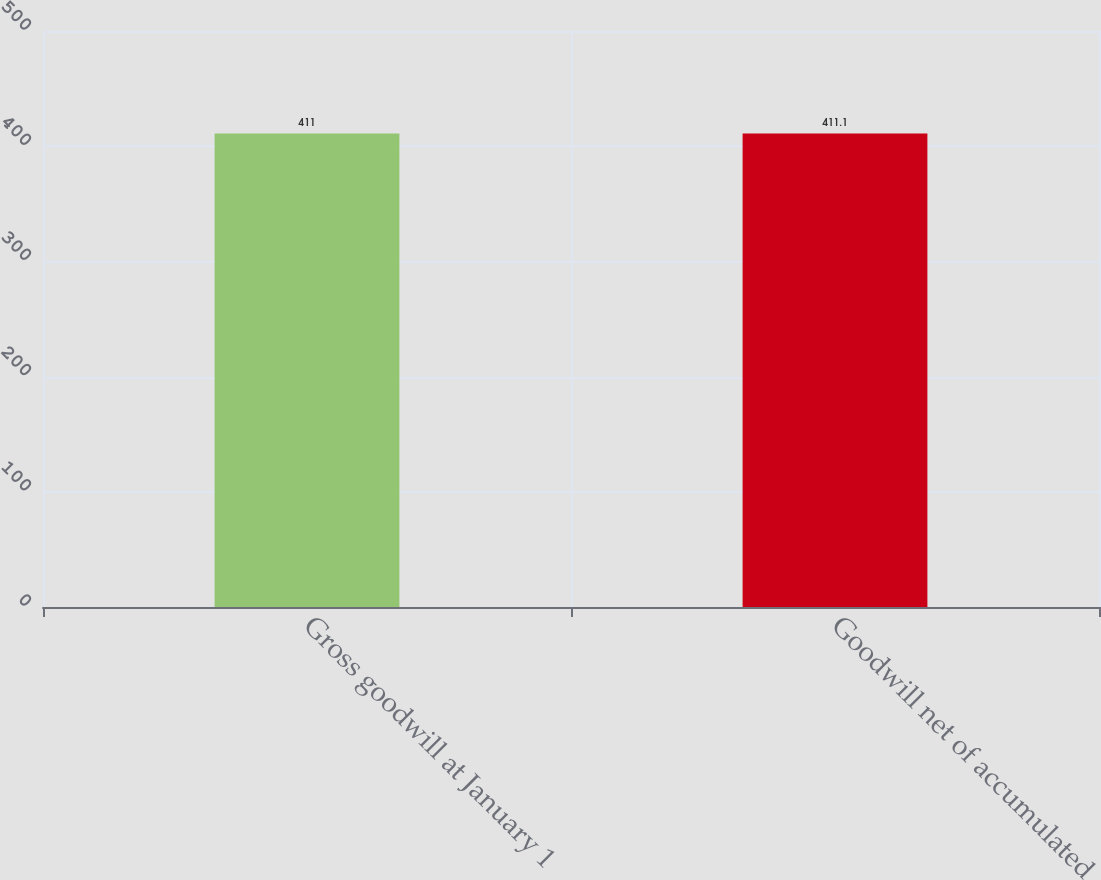<chart> <loc_0><loc_0><loc_500><loc_500><bar_chart><fcel>Gross goodwill at January 1<fcel>Goodwill net of accumulated<nl><fcel>411<fcel>411.1<nl></chart> 